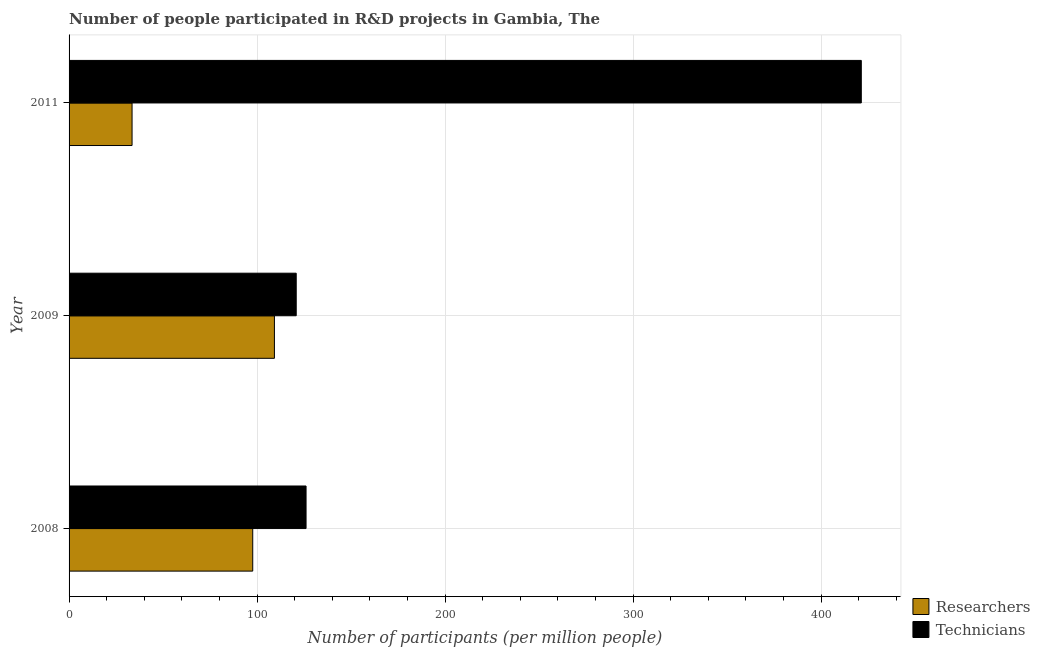How many different coloured bars are there?
Offer a terse response. 2. Are the number of bars per tick equal to the number of legend labels?
Provide a short and direct response. Yes. Are the number of bars on each tick of the Y-axis equal?
Offer a terse response. Yes. How many bars are there on the 2nd tick from the bottom?
Offer a terse response. 2. In how many cases, is the number of bars for a given year not equal to the number of legend labels?
Your response must be concise. 0. What is the number of technicians in 2011?
Provide a short and direct response. 421.36. Across all years, what is the maximum number of technicians?
Provide a short and direct response. 421.36. Across all years, what is the minimum number of technicians?
Ensure brevity in your answer.  120.81. In which year was the number of technicians minimum?
Make the answer very short. 2009. What is the total number of technicians in the graph?
Offer a very short reply. 668.22. What is the difference between the number of researchers in 2008 and that in 2009?
Give a very brief answer. -11.54. What is the difference between the number of researchers in 2011 and the number of technicians in 2008?
Offer a very short reply. -92.54. What is the average number of researchers per year?
Your answer should be very brief. 80.14. In the year 2009, what is the difference between the number of technicians and number of researchers?
Give a very brief answer. 11.59. What is the ratio of the number of researchers in 2009 to that in 2011?
Offer a very short reply. 3.26. Is the number of technicians in 2008 less than that in 2011?
Offer a terse response. Yes. Is the difference between the number of technicians in 2009 and 2011 greater than the difference between the number of researchers in 2009 and 2011?
Offer a very short reply. No. What is the difference between the highest and the second highest number of researchers?
Offer a very short reply. 11.54. What is the difference between the highest and the lowest number of technicians?
Make the answer very short. 300.55. What does the 2nd bar from the top in 2011 represents?
Your response must be concise. Researchers. What does the 1st bar from the bottom in 2008 represents?
Your answer should be compact. Researchers. Are all the bars in the graph horizontal?
Your answer should be compact. Yes. What is the difference between two consecutive major ticks on the X-axis?
Your answer should be very brief. 100. Does the graph contain any zero values?
Give a very brief answer. No. Does the graph contain grids?
Provide a short and direct response. Yes. Where does the legend appear in the graph?
Make the answer very short. Bottom right. How are the legend labels stacked?
Offer a terse response. Vertical. What is the title of the graph?
Your answer should be very brief. Number of people participated in R&D projects in Gambia, The. Does "UN agencies" appear as one of the legend labels in the graph?
Give a very brief answer. No. What is the label or title of the X-axis?
Your answer should be very brief. Number of participants (per million people). What is the label or title of the Y-axis?
Provide a short and direct response. Year. What is the Number of participants (per million people) of Researchers in 2008?
Your answer should be very brief. 97.68. What is the Number of participants (per million people) of Technicians in 2008?
Provide a short and direct response. 126.04. What is the Number of participants (per million people) in Researchers in 2009?
Provide a short and direct response. 109.22. What is the Number of participants (per million people) in Technicians in 2009?
Your answer should be compact. 120.81. What is the Number of participants (per million people) of Researchers in 2011?
Ensure brevity in your answer.  33.5. What is the Number of participants (per million people) in Technicians in 2011?
Provide a short and direct response. 421.36. Across all years, what is the maximum Number of participants (per million people) of Researchers?
Your response must be concise. 109.22. Across all years, what is the maximum Number of participants (per million people) of Technicians?
Provide a short and direct response. 421.36. Across all years, what is the minimum Number of participants (per million people) of Researchers?
Your answer should be compact. 33.5. Across all years, what is the minimum Number of participants (per million people) of Technicians?
Make the answer very short. 120.81. What is the total Number of participants (per million people) in Researchers in the graph?
Ensure brevity in your answer.  240.41. What is the total Number of participants (per million people) in Technicians in the graph?
Your answer should be very brief. 668.22. What is the difference between the Number of participants (per million people) in Researchers in 2008 and that in 2009?
Your answer should be very brief. -11.54. What is the difference between the Number of participants (per million people) of Technicians in 2008 and that in 2009?
Provide a short and direct response. 5.23. What is the difference between the Number of participants (per million people) of Researchers in 2008 and that in 2011?
Make the answer very short. 64.18. What is the difference between the Number of participants (per million people) of Technicians in 2008 and that in 2011?
Your answer should be compact. -295.32. What is the difference between the Number of participants (per million people) in Researchers in 2009 and that in 2011?
Keep it short and to the point. 75.72. What is the difference between the Number of participants (per million people) in Technicians in 2009 and that in 2011?
Your answer should be very brief. -300.55. What is the difference between the Number of participants (per million people) of Researchers in 2008 and the Number of participants (per million people) of Technicians in 2009?
Give a very brief answer. -23.13. What is the difference between the Number of participants (per million people) in Researchers in 2008 and the Number of participants (per million people) in Technicians in 2011?
Give a very brief answer. -323.68. What is the difference between the Number of participants (per million people) of Researchers in 2009 and the Number of participants (per million people) of Technicians in 2011?
Offer a very short reply. -312.14. What is the average Number of participants (per million people) in Researchers per year?
Your answer should be very brief. 80.14. What is the average Number of participants (per million people) in Technicians per year?
Keep it short and to the point. 222.74. In the year 2008, what is the difference between the Number of participants (per million people) of Researchers and Number of participants (per million people) of Technicians?
Give a very brief answer. -28.36. In the year 2009, what is the difference between the Number of participants (per million people) in Researchers and Number of participants (per million people) in Technicians?
Your answer should be compact. -11.59. In the year 2011, what is the difference between the Number of participants (per million people) in Researchers and Number of participants (per million people) in Technicians?
Your answer should be very brief. -387.86. What is the ratio of the Number of participants (per million people) of Researchers in 2008 to that in 2009?
Your response must be concise. 0.89. What is the ratio of the Number of participants (per million people) of Technicians in 2008 to that in 2009?
Your answer should be very brief. 1.04. What is the ratio of the Number of participants (per million people) in Researchers in 2008 to that in 2011?
Give a very brief answer. 2.92. What is the ratio of the Number of participants (per million people) in Technicians in 2008 to that in 2011?
Keep it short and to the point. 0.3. What is the ratio of the Number of participants (per million people) of Researchers in 2009 to that in 2011?
Give a very brief answer. 3.26. What is the ratio of the Number of participants (per million people) of Technicians in 2009 to that in 2011?
Give a very brief answer. 0.29. What is the difference between the highest and the second highest Number of participants (per million people) of Researchers?
Keep it short and to the point. 11.54. What is the difference between the highest and the second highest Number of participants (per million people) in Technicians?
Give a very brief answer. 295.32. What is the difference between the highest and the lowest Number of participants (per million people) of Researchers?
Make the answer very short. 75.72. What is the difference between the highest and the lowest Number of participants (per million people) in Technicians?
Offer a very short reply. 300.55. 